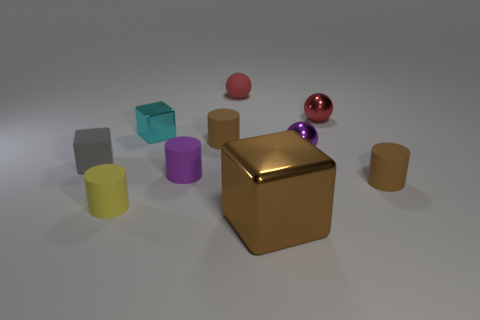Are there more large brown blocks that are in front of the small cyan thing than tiny green blocks?
Ensure brevity in your answer.  Yes. Are there any other things that have the same color as the big metal thing?
Give a very brief answer. Yes. There is a brown object right of the metallic cube that is to the right of the cyan metal thing; what is its shape?
Offer a terse response. Cylinder. Is the number of cyan metallic things greater than the number of brown rubber cylinders?
Keep it short and to the point. No. What number of small things are both to the left of the purple matte cylinder and in front of the cyan metal object?
Your response must be concise. 2. What number of tiny rubber things are behind the tiny cylinder that is to the left of the purple cylinder?
Provide a succinct answer. 5. What number of objects are either metal objects that are right of the cyan shiny block or objects that are in front of the yellow matte thing?
Provide a succinct answer. 3. There is a brown thing that is the same shape as the small cyan thing; what material is it?
Offer a terse response. Metal. How many things are either brown things behind the small yellow matte cylinder or large cubes?
Your response must be concise. 3. The small yellow thing that is made of the same material as the tiny gray cube is what shape?
Your answer should be compact. Cylinder. 